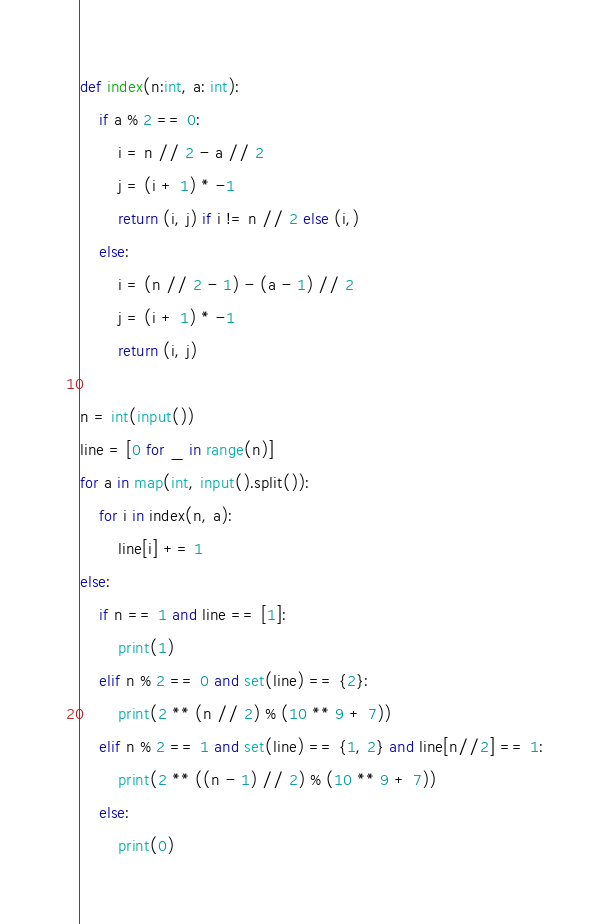<code> <loc_0><loc_0><loc_500><loc_500><_Python_>def index(n:int, a: int):
    if a % 2 == 0:
        i = n // 2 - a // 2
        j = (i + 1) * -1
        return (i, j) if i != n // 2 else (i,)
    else:
        i = (n // 2 - 1) - (a - 1) // 2
        j = (i + 1) * -1
        return (i, j)

n = int(input())
line = [0 for _ in range(n)]
for a in map(int, input().split()):
    for i in index(n, a):
        line[i] += 1
else:
    if n == 1 and line == [1]:
        print(1)
    elif n % 2 == 0 and set(line) == {2}:
        print(2 ** (n // 2) % (10 ** 9 + 7))
    elif n % 2 == 1 and set(line) == {1, 2} and line[n//2] == 1:
        print(2 ** ((n - 1) // 2) % (10 ** 9 + 7))
    else:
        print(0)</code> 